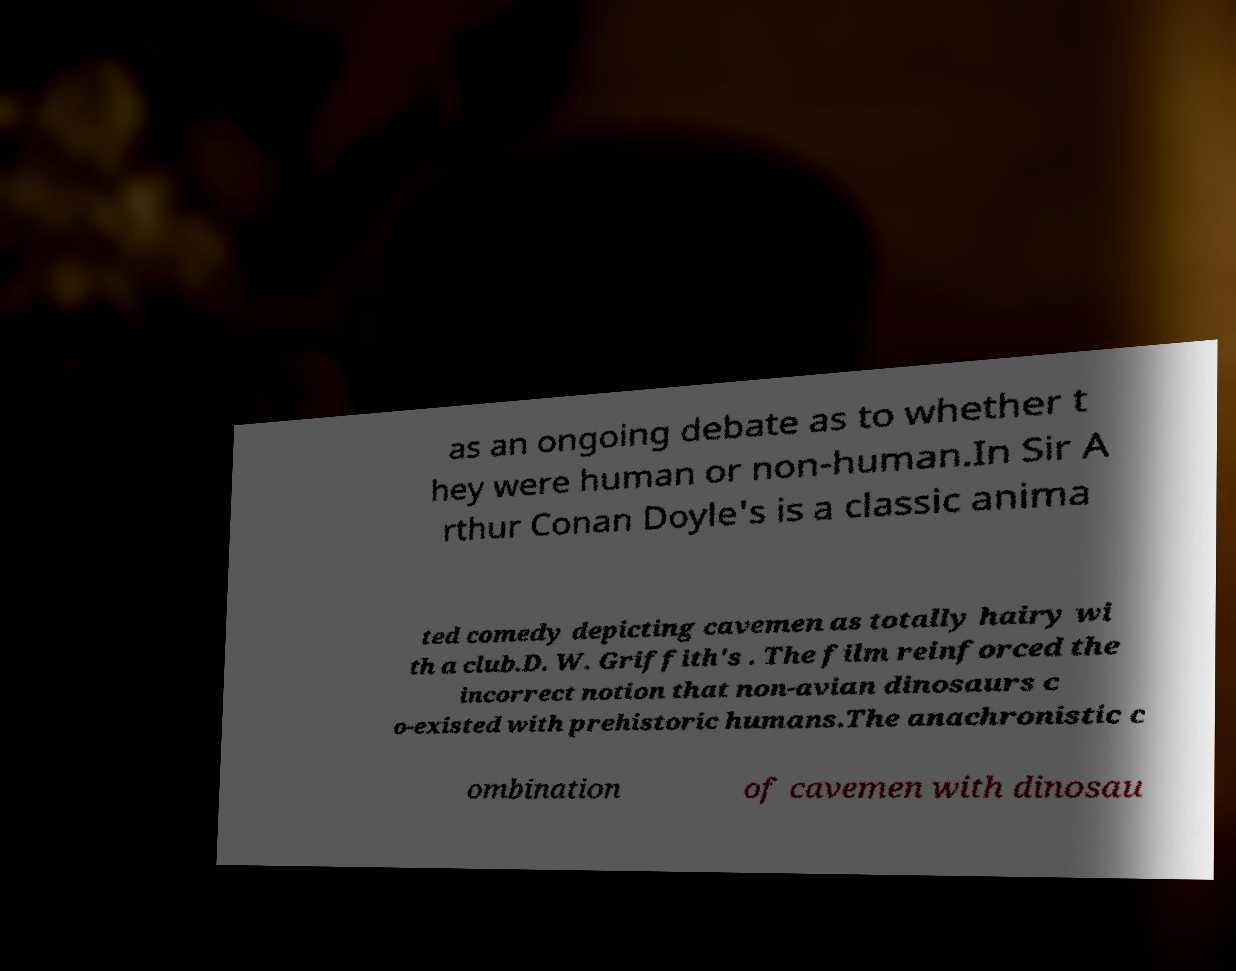Please identify and transcribe the text found in this image. as an ongoing debate as to whether t hey were human or non-human.In Sir A rthur Conan Doyle's is a classic anima ted comedy depicting cavemen as totally hairy wi th a club.D. W. Griffith's . The film reinforced the incorrect notion that non-avian dinosaurs c o-existed with prehistoric humans.The anachronistic c ombination of cavemen with dinosau 